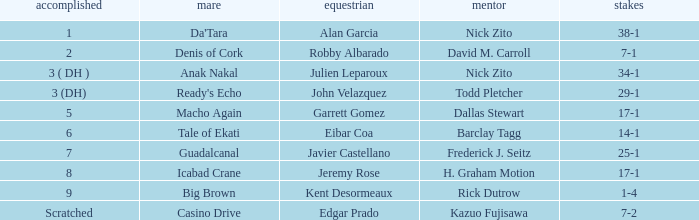What are the Odds for the Horse called Ready's Echo? 29-1. 